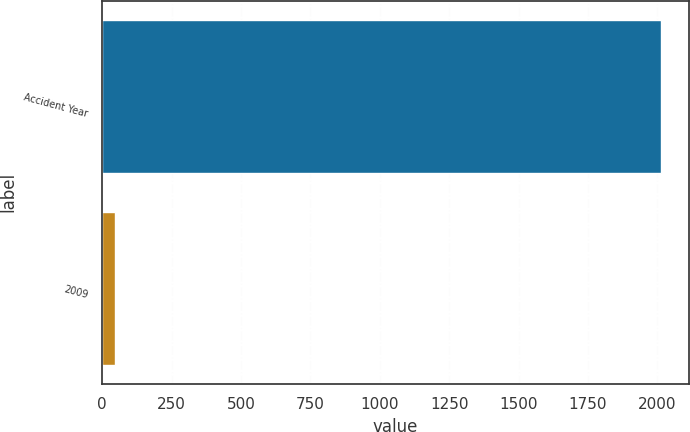Convert chart. <chart><loc_0><loc_0><loc_500><loc_500><bar_chart><fcel>Accident Year<fcel>2009<nl><fcel>2012<fcel>46<nl></chart> 